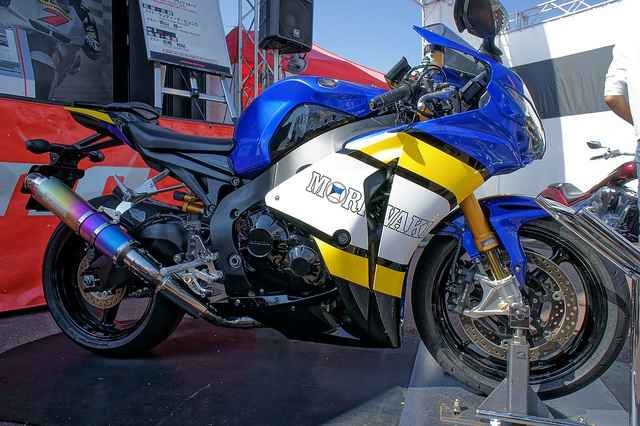Describe the objects in this image and their specific colors. I can see motorcycle in navy, black, gray, and white tones, motorcycle in navy, gray, black, white, and darkgray tones, and people in navy, white, and gray tones in this image. 